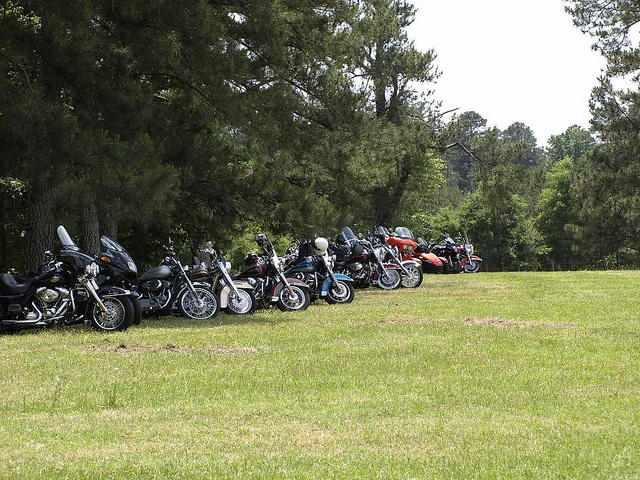Describe the objects in this image and their specific colors. I can see motorcycle in black, gray, lightgray, and darkgray tones, motorcycle in black, gray, and darkgray tones, motorcycle in black, gray, lightgray, and darkgray tones, motorcycle in black, lightgray, gray, and darkgray tones, and motorcycle in black, gray, lightgray, and darkgray tones in this image. 